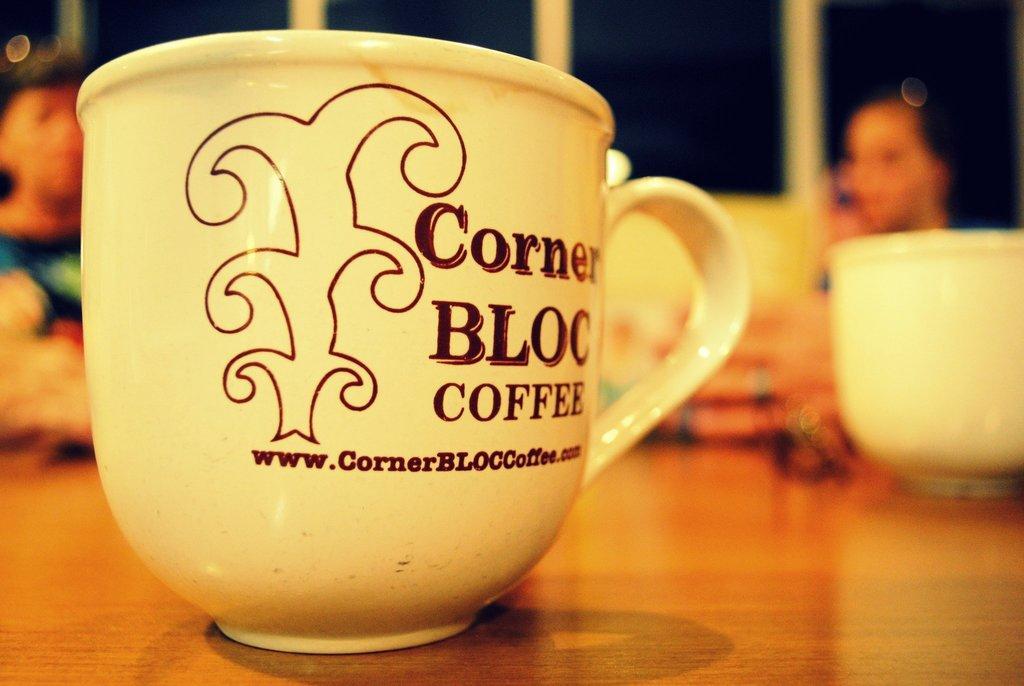How would you summarize this image in a sentence or two? In the center of the image there is a coffee cup on the table. In the background of the image there are people. 